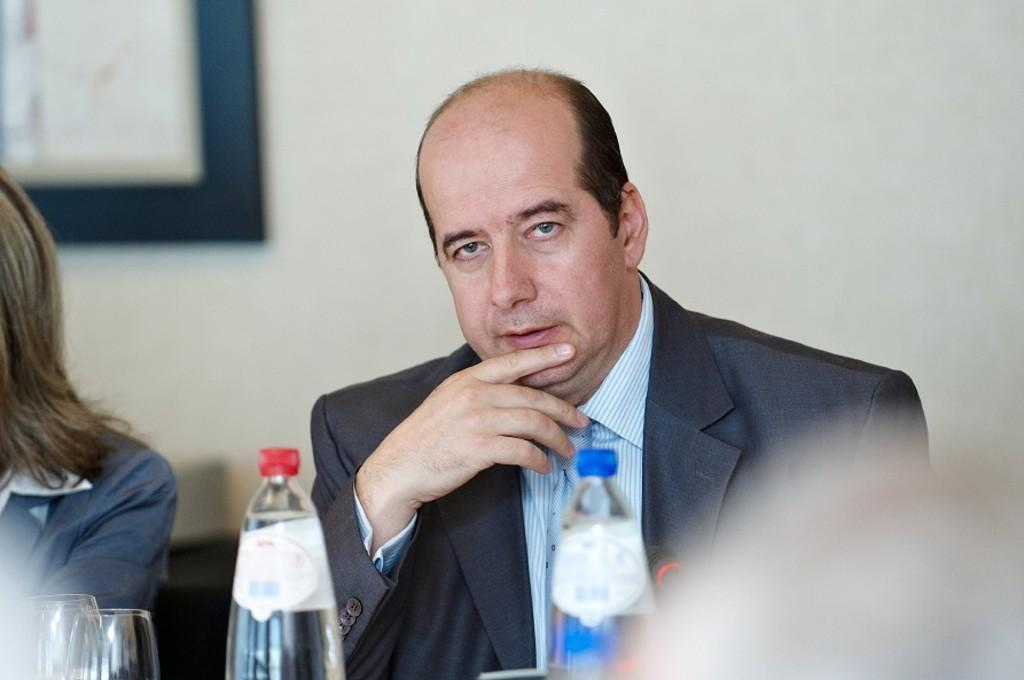Who is present in the image? There is a man in the image. What is the man doing in the image? The man is sitting on a chair. What is in front of the man? There is a table in front of the man. What items can be seen on the table? There are glasses and bottles on the table. What is visible behind the man? The background of the man is a wall. What type of pie is being served in the image? There is no pie present in the image. What time of day is it in the image, given the presence of a hen? There is no hen present in the image, and therefore we cannot determine the time of day based on that information. 